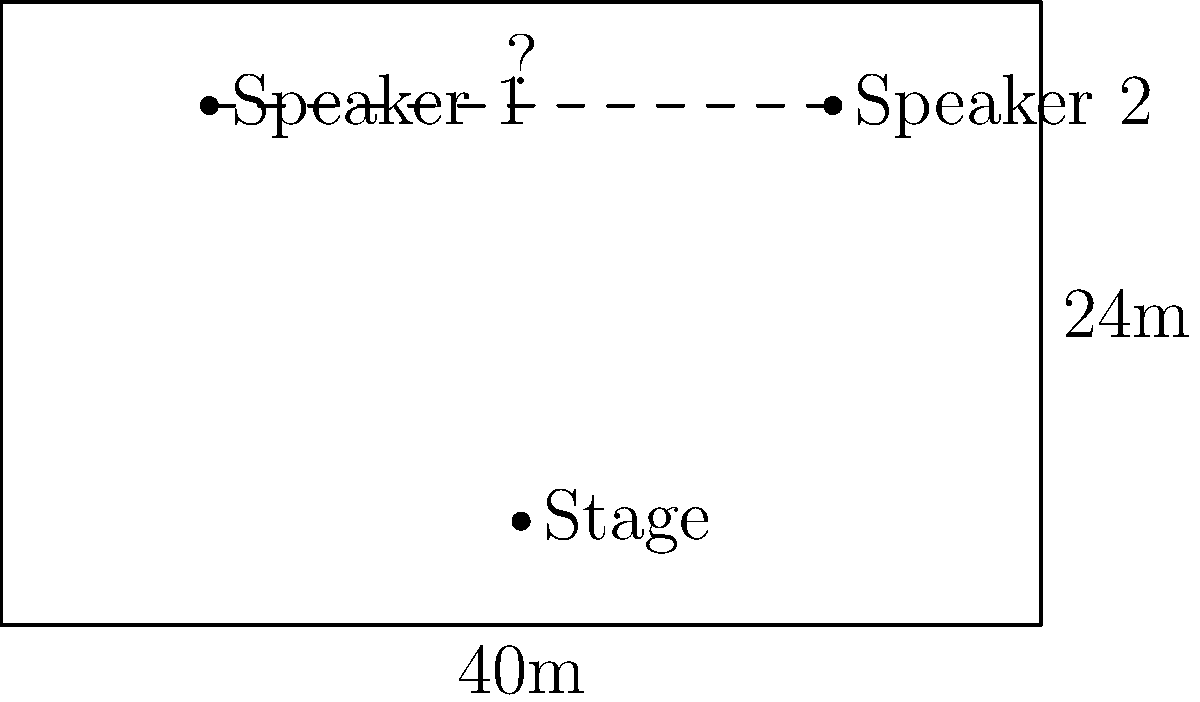As a music producer collaborating with Bette Midler, you need to plan the speaker placement for her upcoming concert. The rectangular venue measures 40m in length and 24m in width. Two speakers are placed 6m from the back wall, directly across from each other. What is the distance between these two speakers? To solve this problem, we'll follow these steps:

1. Identify the relevant information:
   - The venue is 40m long and 24m wide
   - The speakers are 6m from the back wall
   - The speakers are directly across from each other

2. Visualize the problem:
   - The speakers form a line parallel to the width of the venue
   - This line is 6m from the back wall

3. Calculate the distance:
   - The distance between the speakers is equal to the width of the venue
   - Width of the venue = 24m

4. Verify the answer:
   - The distance between the speakers should be less than the length of the venue (40m)
   - 24m is indeed less than 40m, so our answer is plausible

Therefore, the distance between the two speakers is 24m.
Answer: 24m 